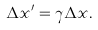<formula> <loc_0><loc_0><loc_500><loc_500>\Delta x ^ { \prime } = \gamma \Delta x .</formula> 